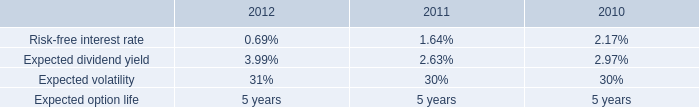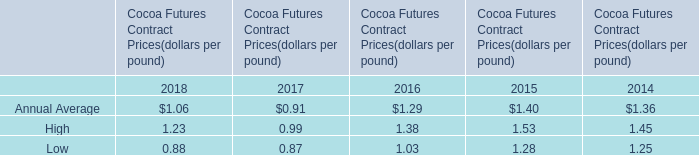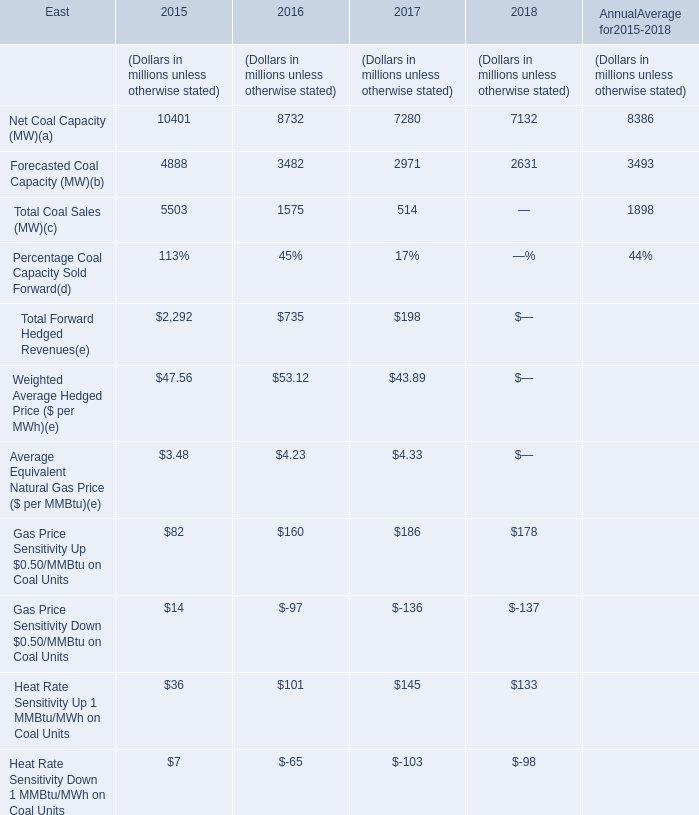What is the growing rate of Net Coal Capacity in the years with the least Forecasted Coal Capacity? 
Computations: ((7132 - 7280) / 7132)
Answer: -0.02075. 